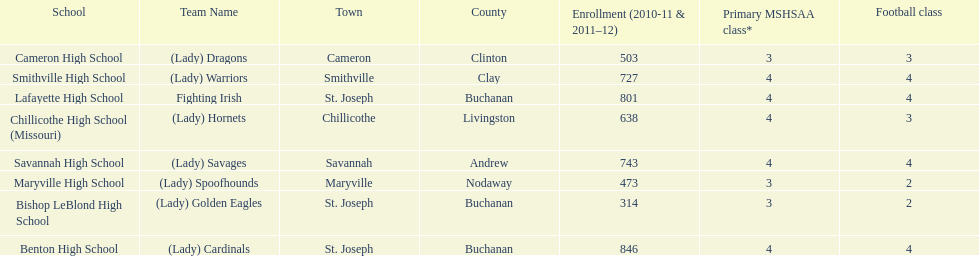What school has 3 football classes but only has 638 student enrollment? Chillicothe High School (Missouri). 